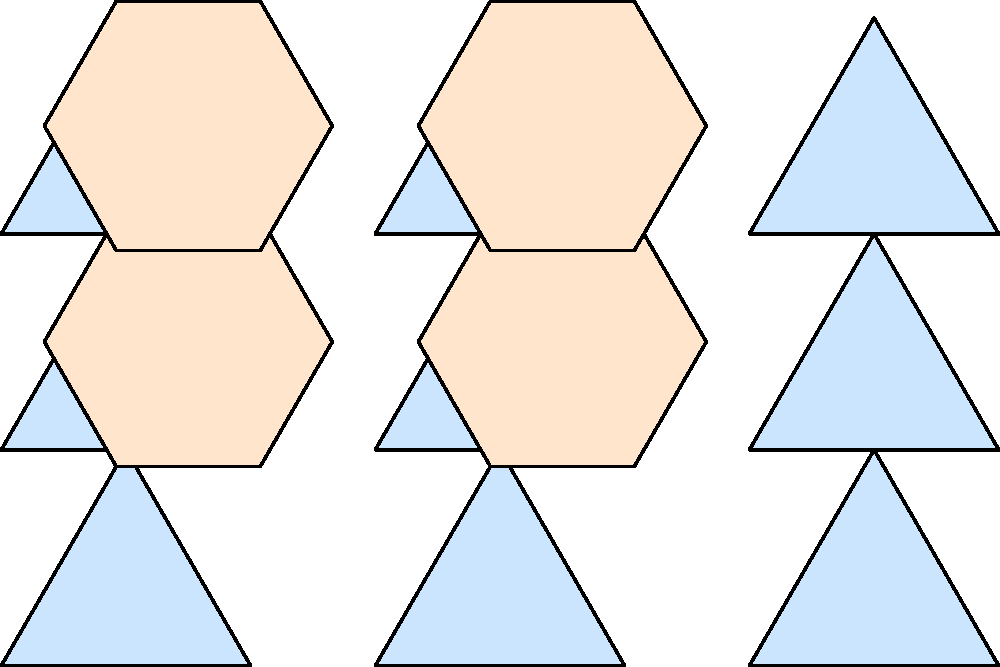In the tessellation shown, equilateral triangles and regular hexagons are used to create a repeating pattern. If the side length of each triangle is $a$ units, what is the area of one hexagon in the tessellation in terms of $a$? Let's approach this step-by-step:

1) First, we need to understand the relationship between the triangles and hexagons in this tessellation.

2) Notice that each hexagon is surrounded by 6 equilateral triangles.

3) The side length of the hexagon is equal to the height of the equilateral triangle.

4) For an equilateral triangle with side length $a$, the height $h$ is given by:
   $h = \frac{\sqrt{3}}{2}a$

5) So, the side length of the hexagon is $\frac{\sqrt{3}}{2}a$.

6) The area of a regular hexagon with side length $s$ is given by:
   $A = \frac{3\sqrt{3}}{2}s^2$

7) Substituting $s = \frac{\sqrt{3}}{2}a$ into this formula:
   $A = \frac{3\sqrt{3}}{2}(\frac{\sqrt{3}}{2}a)^2$

8) Simplifying:
   $A = \frac{3\sqrt{3}}{2} \cdot \frac{3}{4}a^2 = \frac{9\sqrt{3}}{8}a^2$

Therefore, the area of one hexagon in the tessellation is $\frac{9\sqrt{3}}{8}a^2$ square units.
Answer: $\frac{9\sqrt{3}}{8}a^2$ square units 